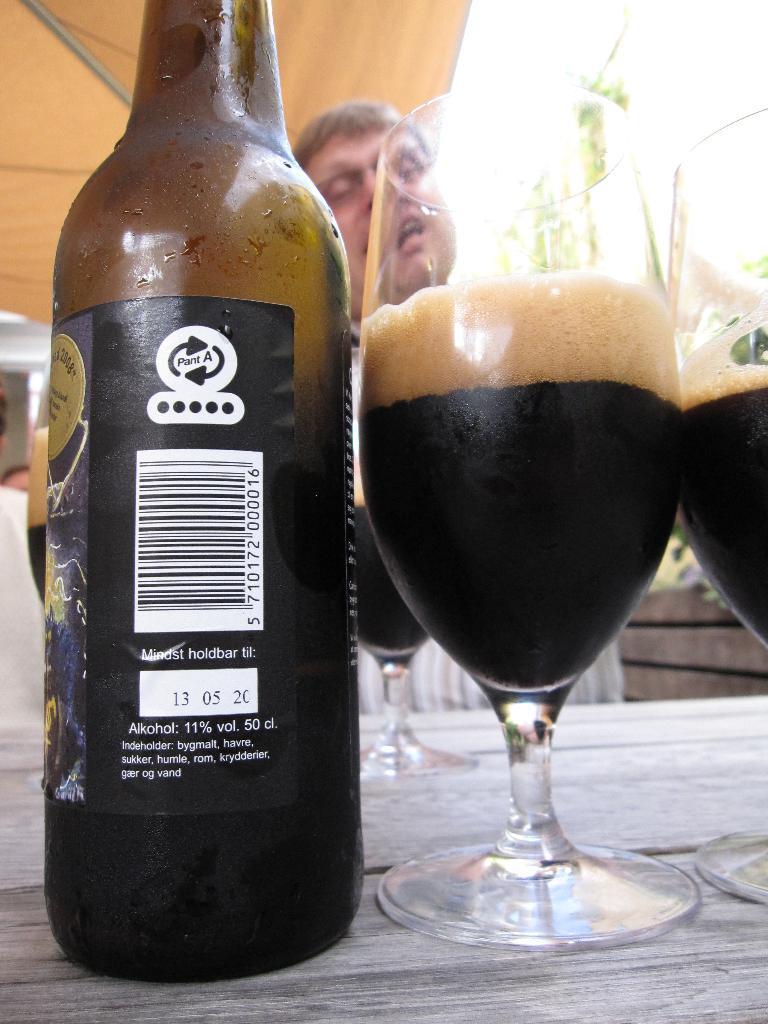Can you describe this image briefly? In this image I can see a bottle and a glass on the table. 